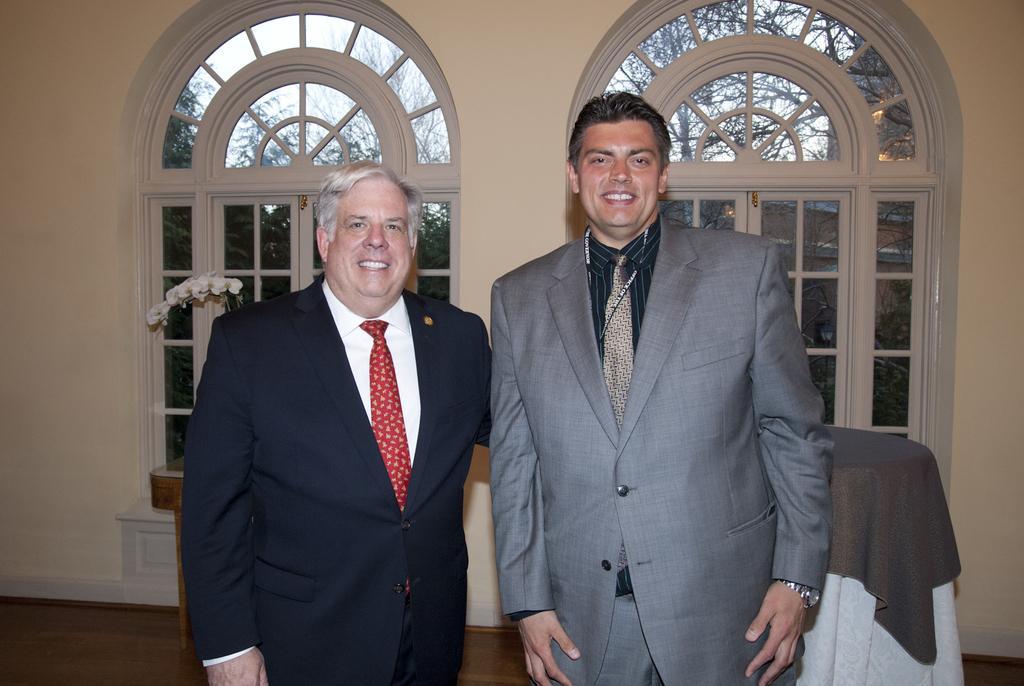In one or two sentences, can you explain what this image depicts? In this picture, we see two men are standing. Both of them are smiling and they are posing for the photo. Behind them, we see a flower pot and a table which is covered with the grey and white color cloth. In the background, we see a wall and the glass doors or windows from which we can see the trees and the sky. 